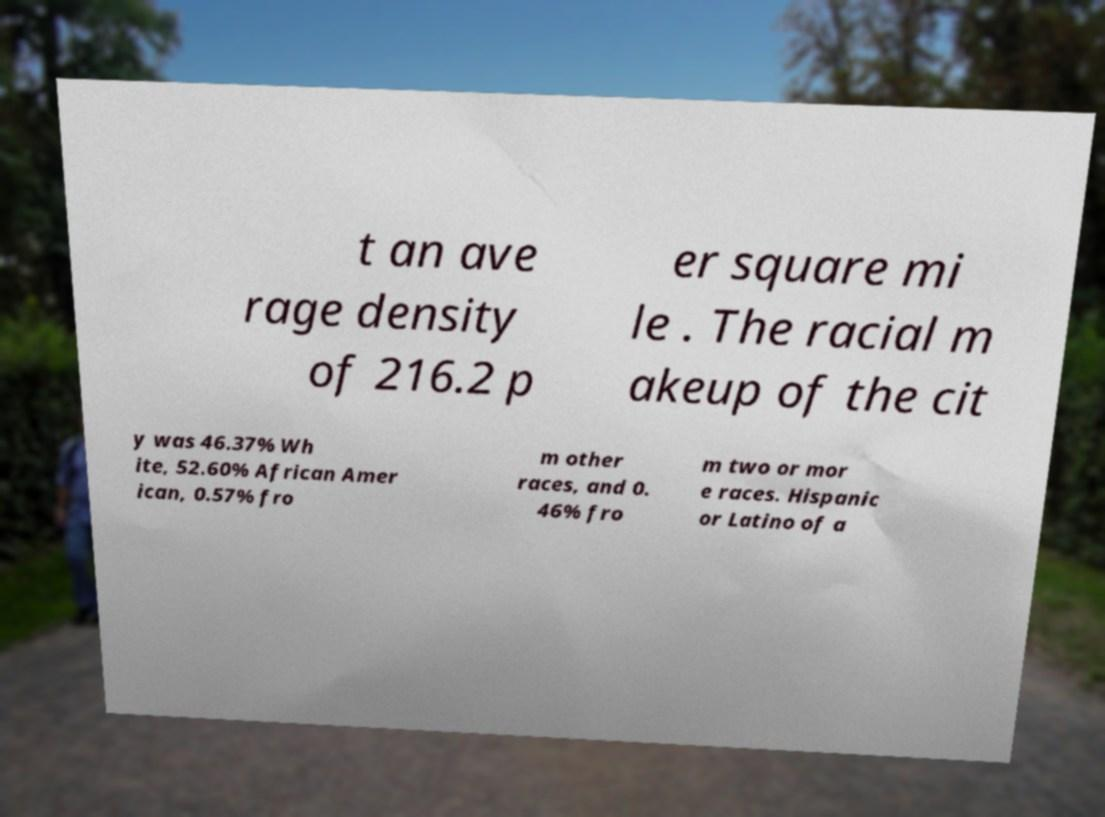Could you assist in decoding the text presented in this image and type it out clearly? t an ave rage density of 216.2 p er square mi le . The racial m akeup of the cit y was 46.37% Wh ite, 52.60% African Amer ican, 0.57% fro m other races, and 0. 46% fro m two or mor e races. Hispanic or Latino of a 